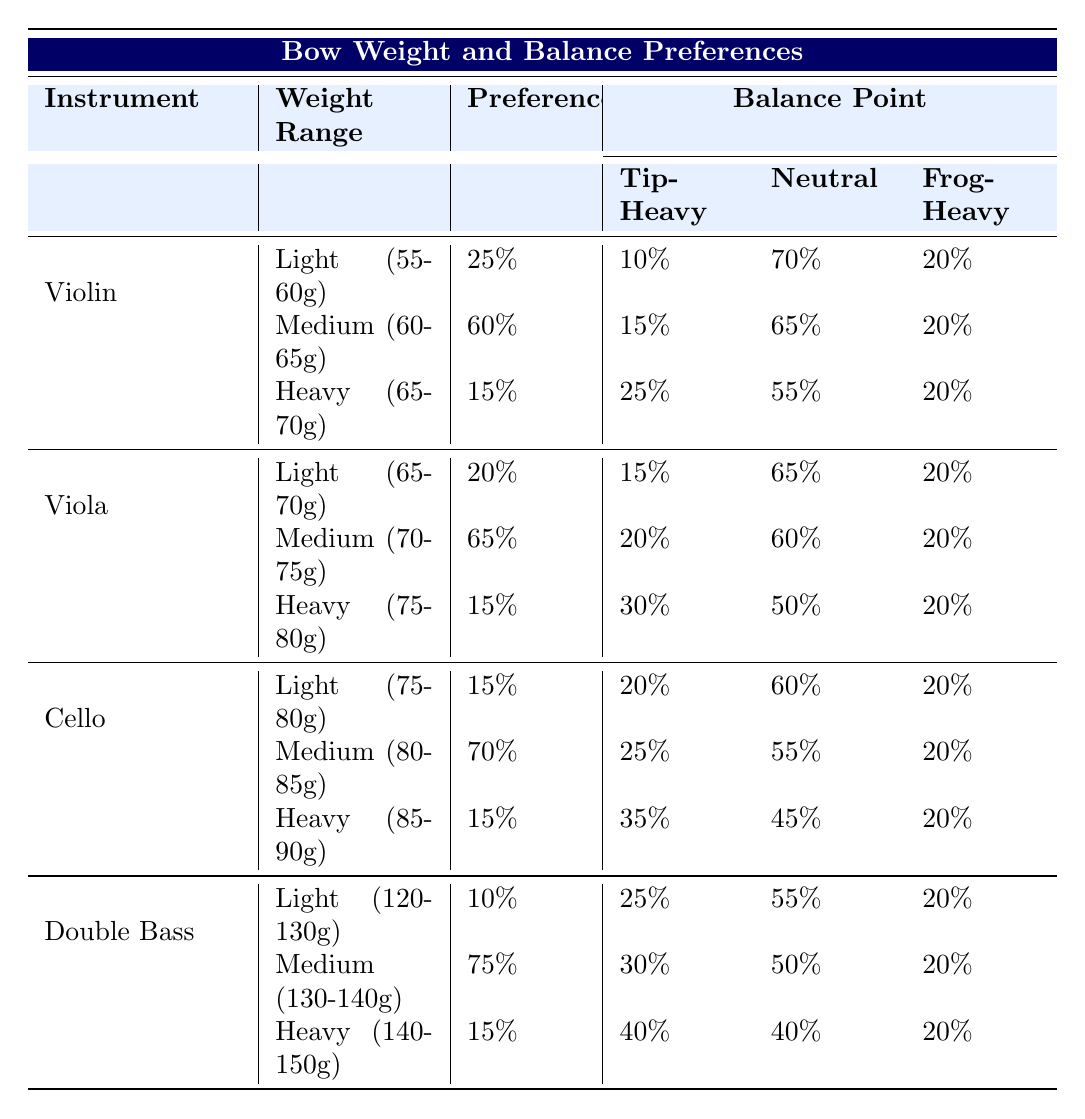What percentage of violinists prefer a medium bow weight? The table shows that 60% of violinists prefer a medium bow weight in the range of 60-65g.
Answer: 60% What is the balance point preference for heavy violin bows? For heavy violin bows, the balance point preferences are 25% tip-heavy, 55% neutral, and 20% frog-heavy.
Answer: 25% tip-heavy, 55% neutral, 20% frog-heavy Which instrument has the highest preference for medium bow weight? The cello has the highest preference for medium bow weight at 70%, compared to other instruments.
Answer: Cello What is the average preference percentage for light bows across all instruments? Calculating the average preference for light bows: (25% for Violin + 20% for Viola + 15% for Cello + 10% for Double Bass) / 4 = 20%.
Answer: 20% Are violinists more likely to prefer light or heavy bows? The preference for light bows is 25%, while for heavy bows it's only 15%. Thus, violinists are more likely to prefer light bows.
Answer: Yes What is the total percentage of viola players that prefer either light or heavy bows? The total percentage for viola players who prefer light (20%) or heavy bows (15%) is 20% + 15% = 35%.
Answer: 35% Which type of instrument has the least preference for light bows? The double bass has the least preference for light bows at 10%.
Answer: Double Bass Which balance point preference is most common among professional cellists for medium weight bows? For medium weight cello bows, the most common balance point preference is neutral at 55%.
Answer: Neutral 55% If a violinist prefers a neutral balance, what can be inferred about their bow weight preference? A preference for neutral balance is most common in the medium weight range, indicating that they likely prefer a medium bow weight.
Answer: Medium bow weight What percentage of double bass players prefer heavy bows? The table indicates that 15% of double bass players prefer heavy bows in the range of 140-150g.
Answer: 15% 